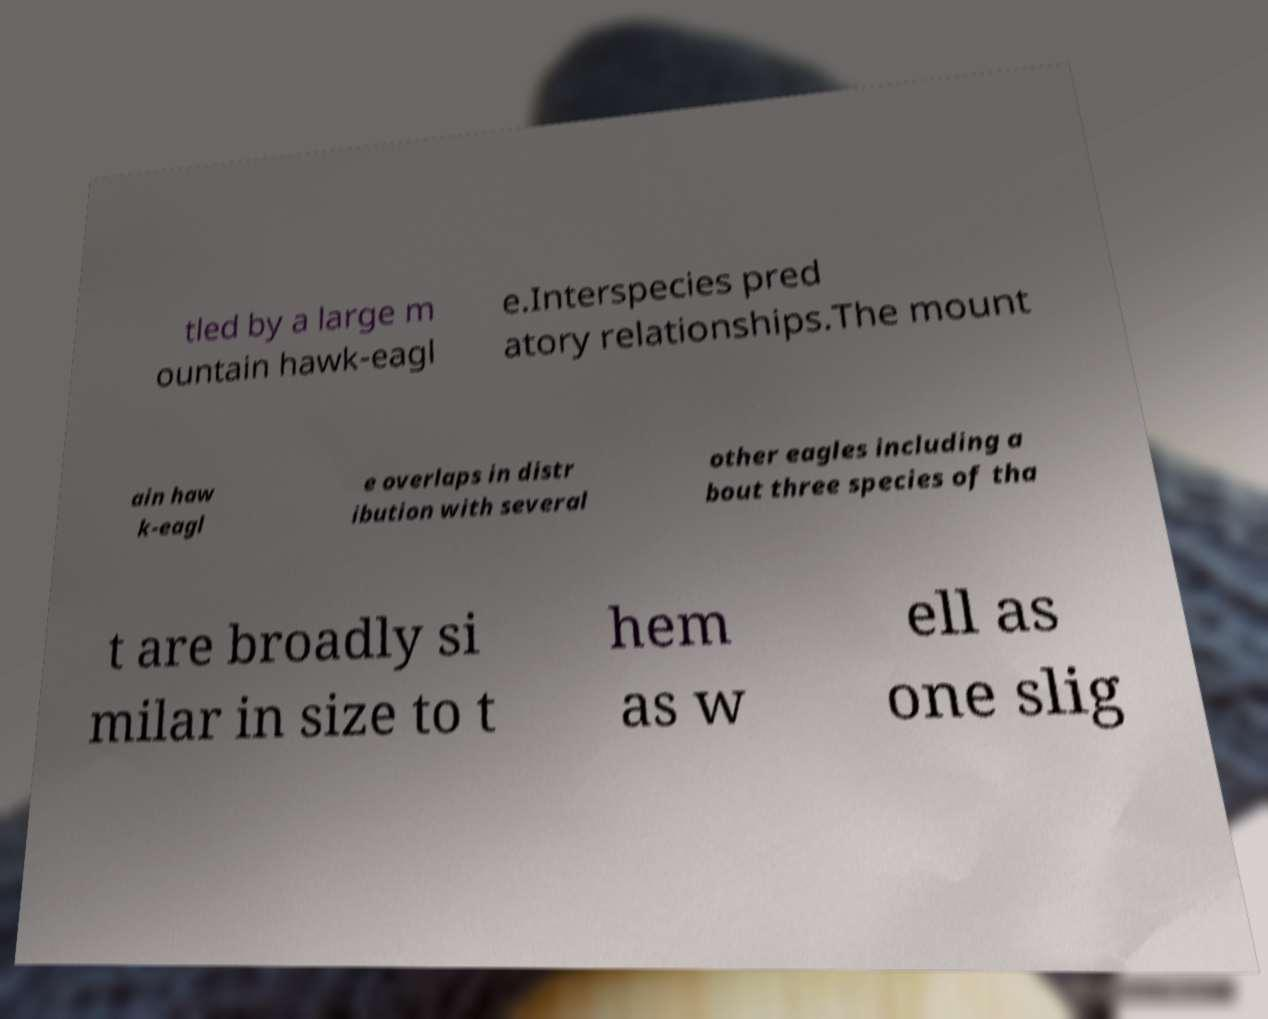I need the written content from this picture converted into text. Can you do that? tled by a large m ountain hawk-eagl e.Interspecies pred atory relationships.The mount ain haw k-eagl e overlaps in distr ibution with several other eagles including a bout three species of tha t are broadly si milar in size to t hem as w ell as one slig 